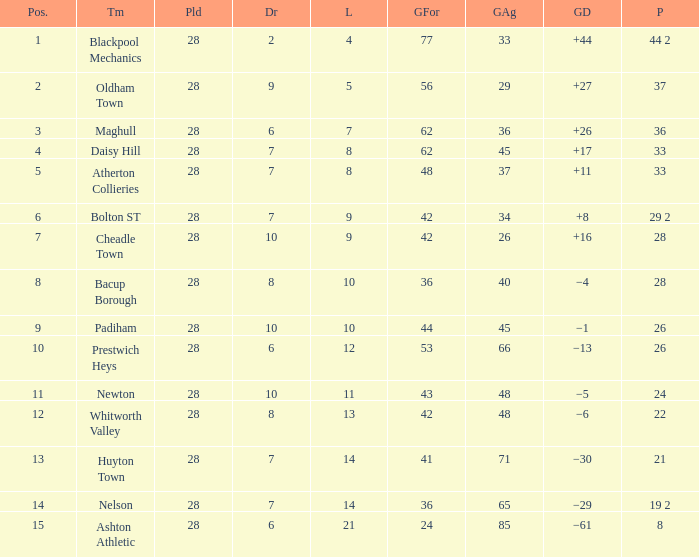What is the average played for entries with fewer than 65 goals against, points 1 of 19 2, and a position higher than 15? None. 